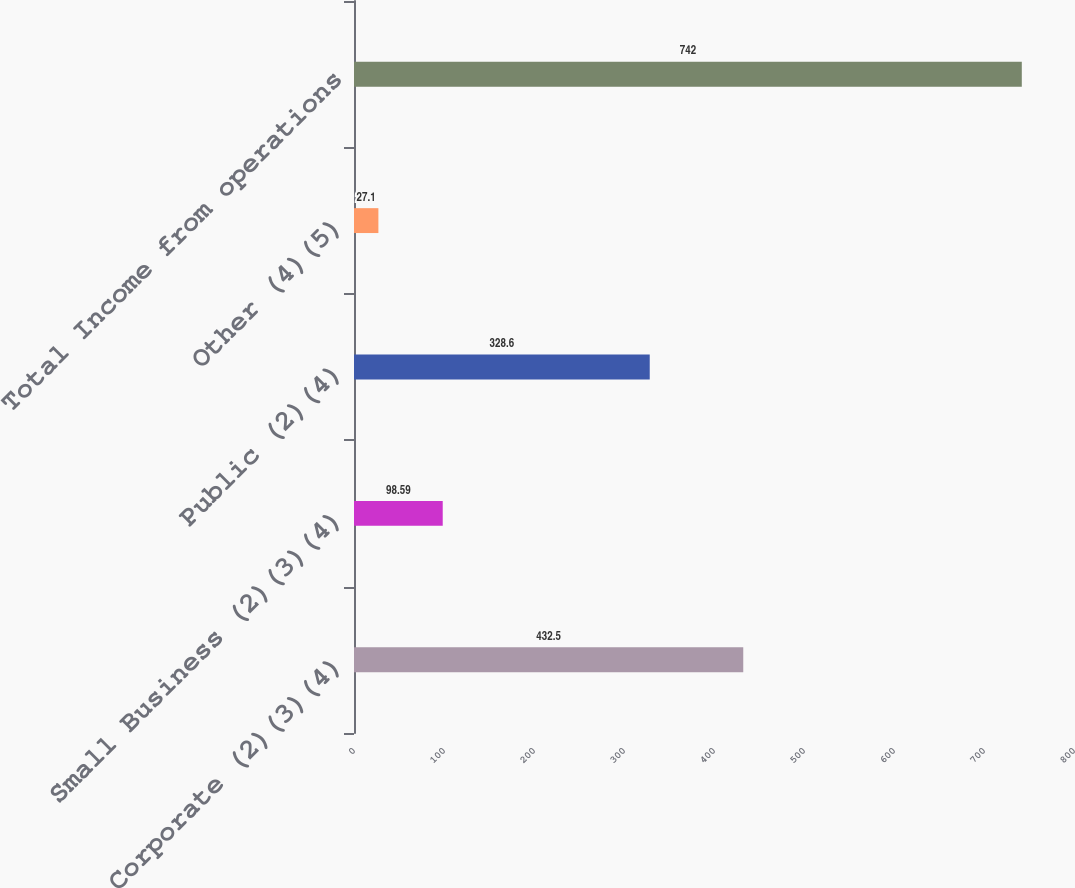Convert chart. <chart><loc_0><loc_0><loc_500><loc_500><bar_chart><fcel>Corporate (2)(3)(4)<fcel>Small Business (2)(3)(4)<fcel>Public (2)(4)<fcel>Other (4)(5)<fcel>Total Income from operations<nl><fcel>432.5<fcel>98.59<fcel>328.6<fcel>27.1<fcel>742<nl></chart> 